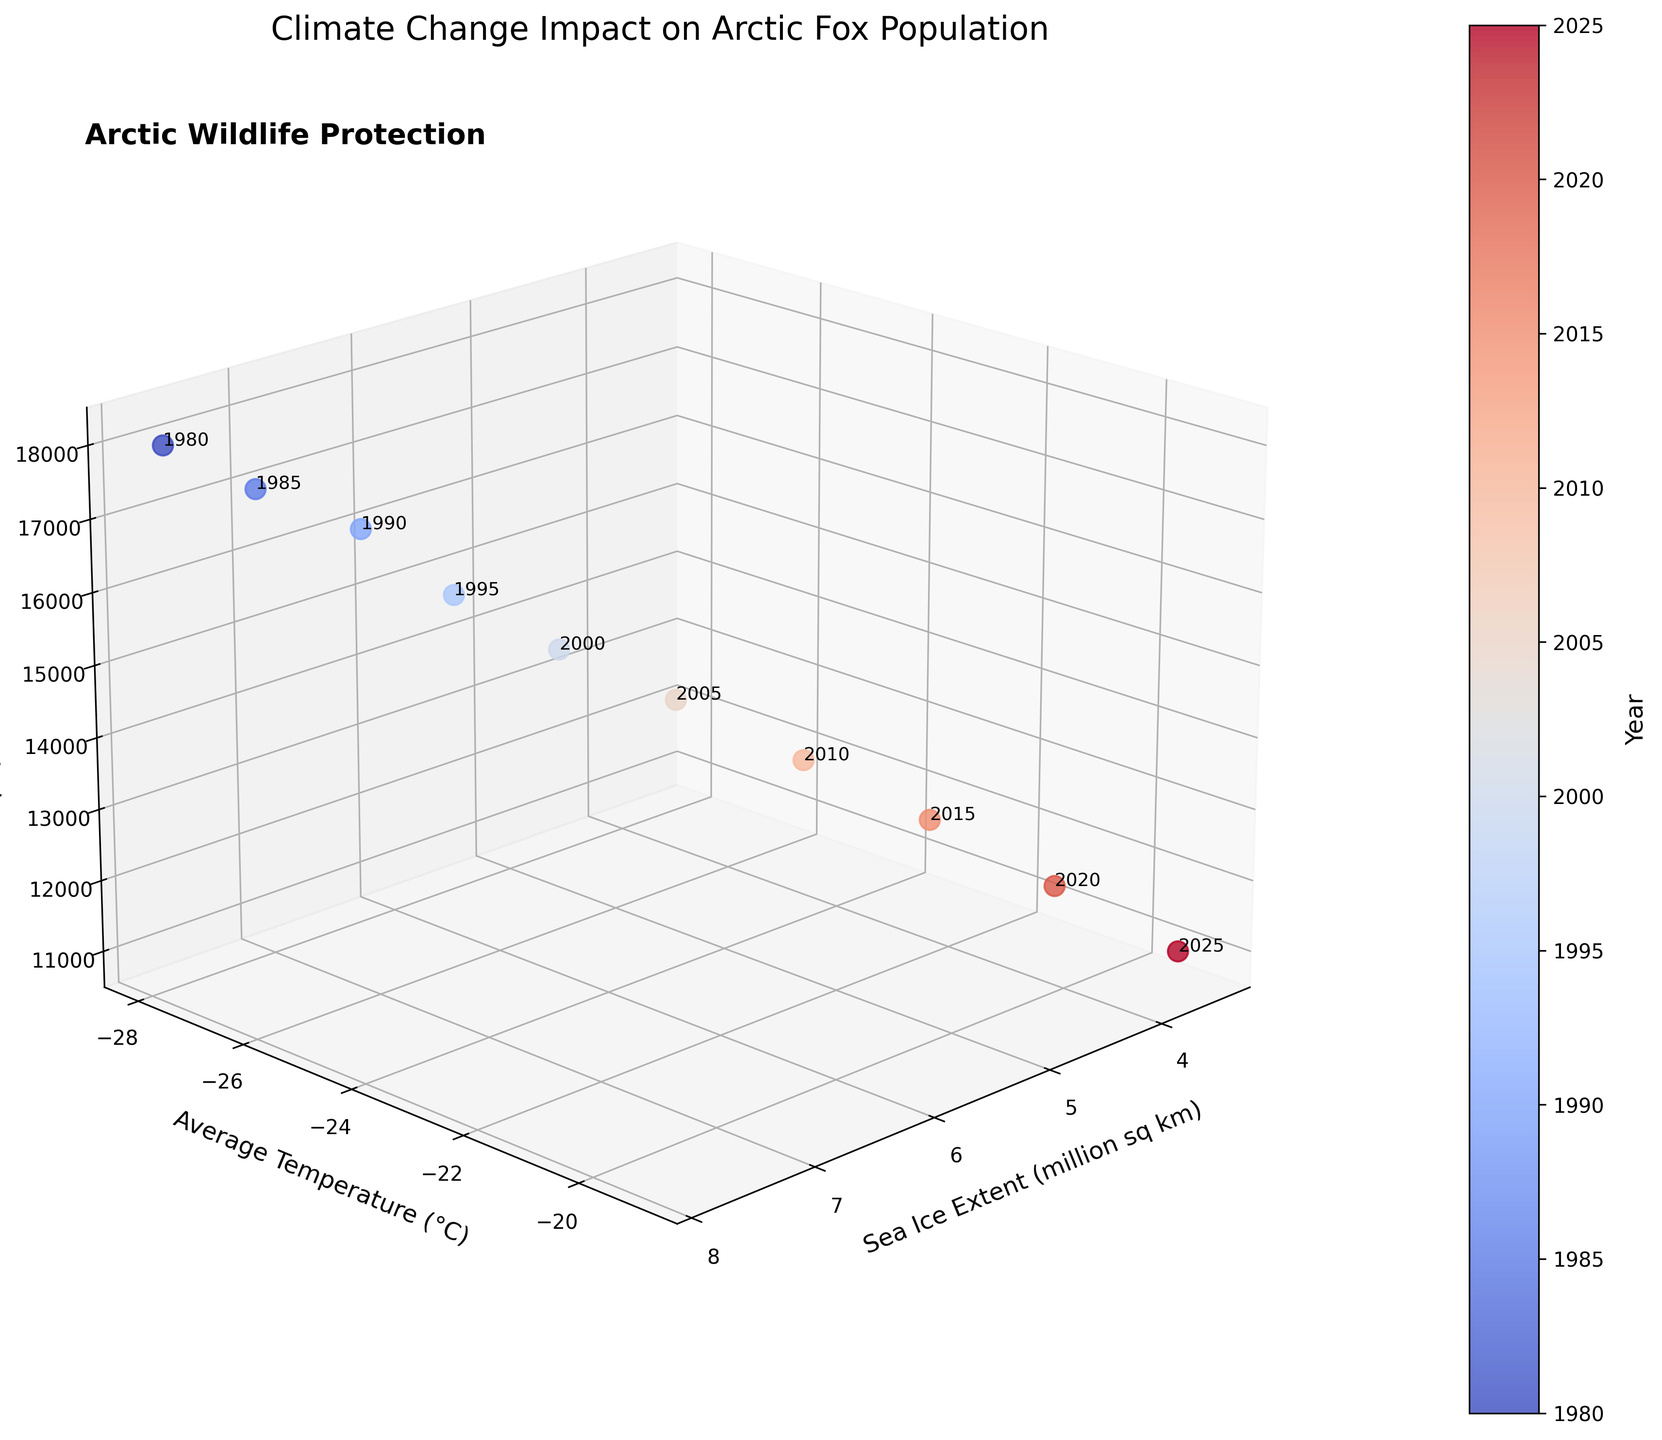What does the title of the figure indicate? The title of the figure is "Climate Change Impact on Arctic Fox Population". It suggests that the plot is about how climate change variables like sea ice extent and average temperature are impacting the population of Arctic foxes over time.
Answer: Climate Change Impact on Arctic Fox Population How many data points are plotted in the figure? There are data points for the years from 1980 to 2025, in 5-year increments, as shown in the data table. There are 10 data points.
Answer: 10 How does the sea ice extent correlate with the average temperature in the plot? As the sea ice extent decreases from around 7.8 million sq km to 3.5 million sq km, the average temperature increases from -28°C to -19°C. This indicates that there is a negative correlation between sea ice extent and temperature.
Answer: Negative correlation Which year shows the highest Arctic Fox population? By examining the 3D plot, the highest Arctic Fox population is labeled around the year 1980 with a population of 18,000.
Answer: 1980 What trend can be observed in the Arctic Fox population over the years shown in the plot? The Arctic Fox population is generally decreasing over the years. It starts from a population of 18,000 in 1980 and decreases steadily to about 11,000 by 2025.
Answer: Decreasing trend What's the sea ice extent in 2015? In the plot, the year 2015 corresponds to a sea ice extent of approximately 4.7 million sq km.
Answer: 4.7 million sq km How much has the Arctic Fox population decreased from 1980 to 2025? The Arctic Fox population was 18,000 in 1980 and decreased to 11,000 by 2025. The decrease is calculated as 18,000 - 11,000.
Answer: 7,000 In which year is the average temperature closest to -22°C? The plot shows that in the year 2010, the average temperature is approximately -22°C.
Answer: 2010 Compare the sea ice extent in 1990 and 2020. Which year had a greater extent? The sea ice extent in 1990 is about 7.1 million sq km, while in 2020 it is about 4.1 million sq km. Thus, 1990 had a greater extent.
Answer: 1990 How is the Arctic Fox population affected as the average temperature increases from -28°C to -19°C? As the average temperature increases from -28°C to -19°C, the Arctic Fox population decreases from 18,000 to 11,000, demonstrating a negative correlation between temperature and fox population.
Answer: Negative correlation 